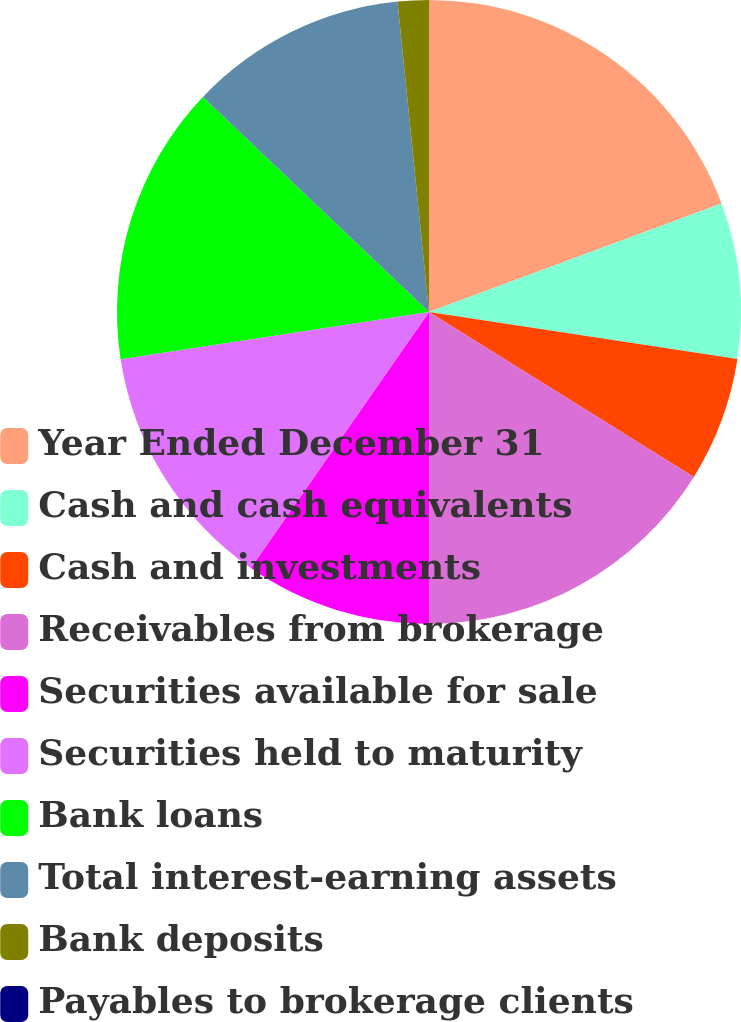<chart> <loc_0><loc_0><loc_500><loc_500><pie_chart><fcel>Year Ended December 31<fcel>Cash and cash equivalents<fcel>Cash and investments<fcel>Receivables from brokerage<fcel>Securities available for sale<fcel>Securities held to maturity<fcel>Bank loans<fcel>Total interest-earning assets<fcel>Bank deposits<fcel>Payables to brokerage clients<nl><fcel>19.35%<fcel>8.06%<fcel>6.45%<fcel>16.13%<fcel>9.68%<fcel>12.9%<fcel>14.52%<fcel>11.29%<fcel>1.61%<fcel>0.0%<nl></chart> 